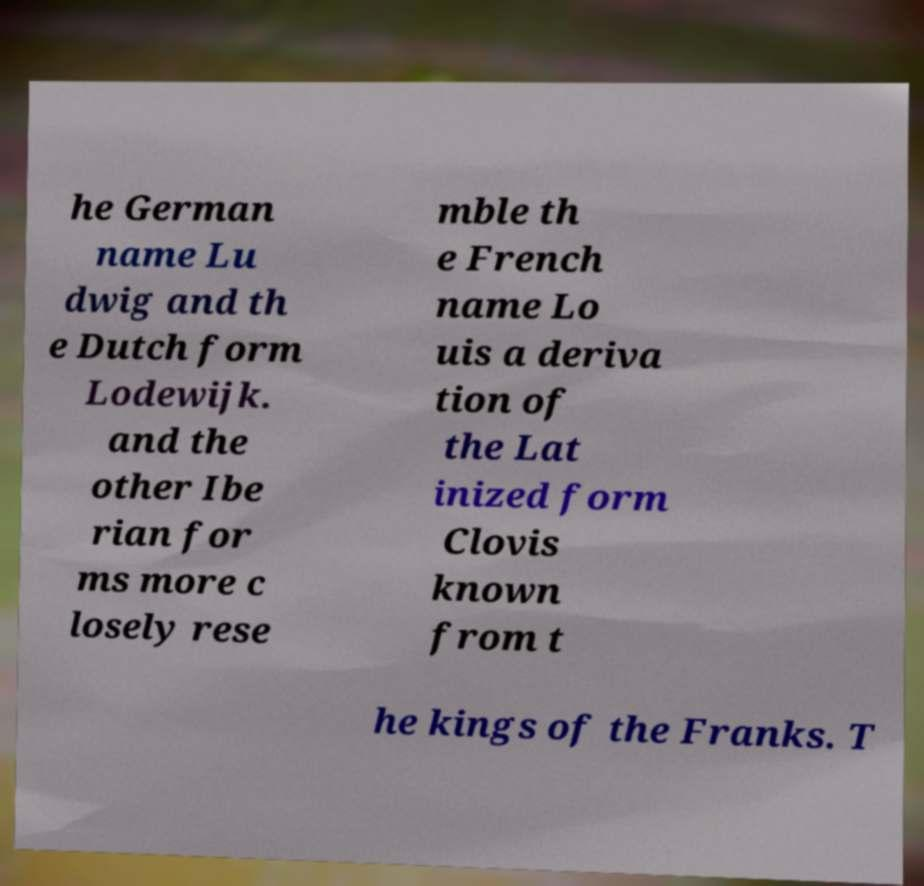For documentation purposes, I need the text within this image transcribed. Could you provide that? he German name Lu dwig and th e Dutch form Lodewijk. and the other Ibe rian for ms more c losely rese mble th e French name Lo uis a deriva tion of the Lat inized form Clovis known from t he kings of the Franks. T 